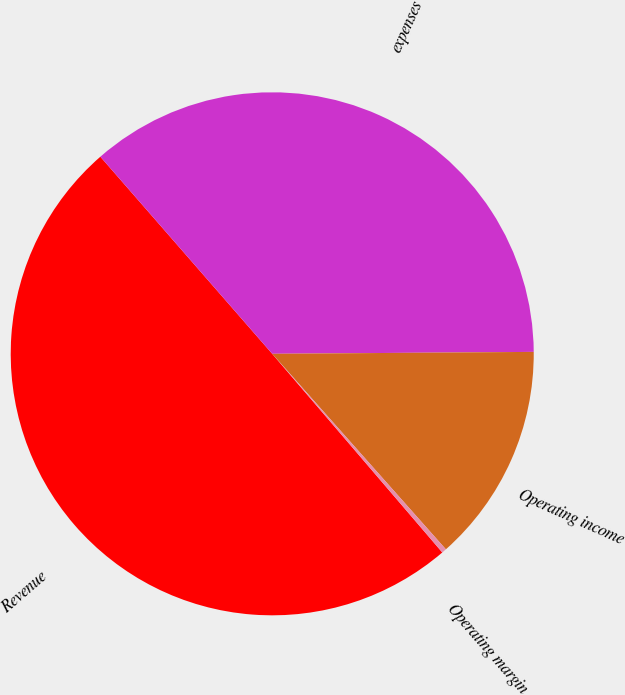<chart> <loc_0><loc_0><loc_500><loc_500><pie_chart><fcel>Revenue<fcel>expenses<fcel>Operating income<fcel>Operating margin<nl><fcel>49.86%<fcel>36.3%<fcel>13.56%<fcel>0.29%<nl></chart> 